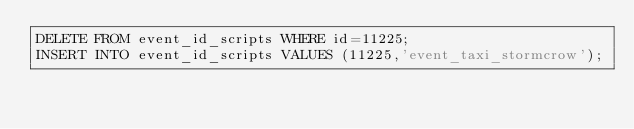Convert code to text. <code><loc_0><loc_0><loc_500><loc_500><_SQL_>DELETE FROM event_id_scripts WHERE id=11225;
INSERT INTO event_id_scripts VALUES (11225,'event_taxi_stormcrow');
</code> 